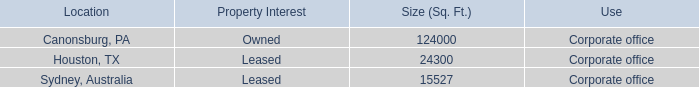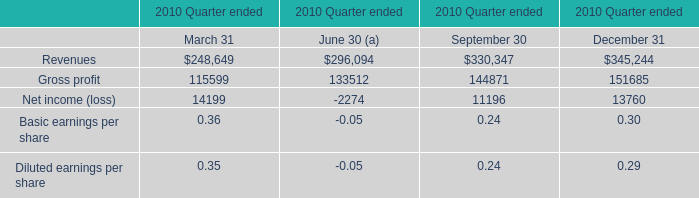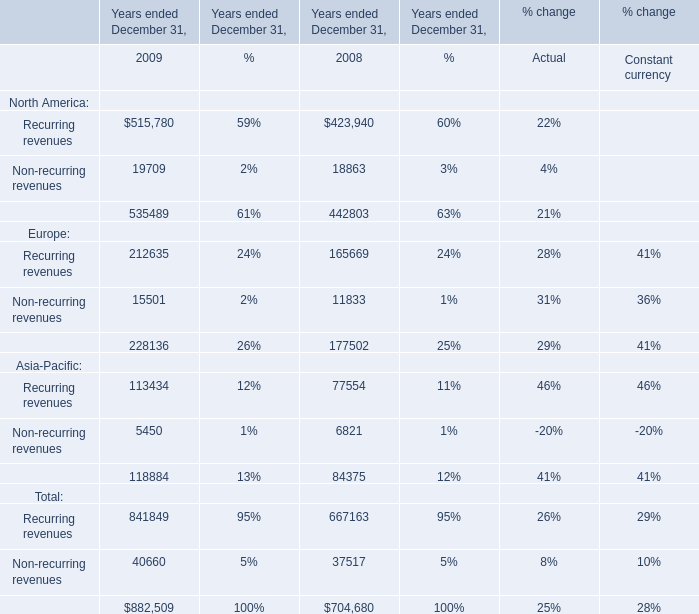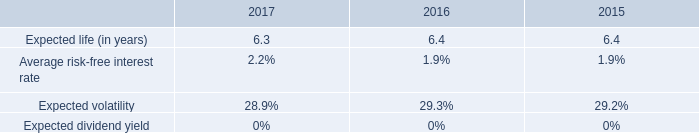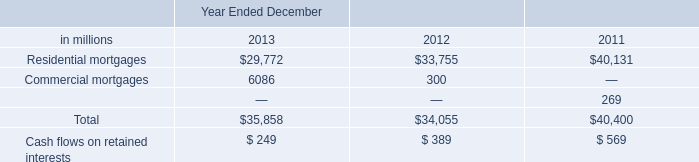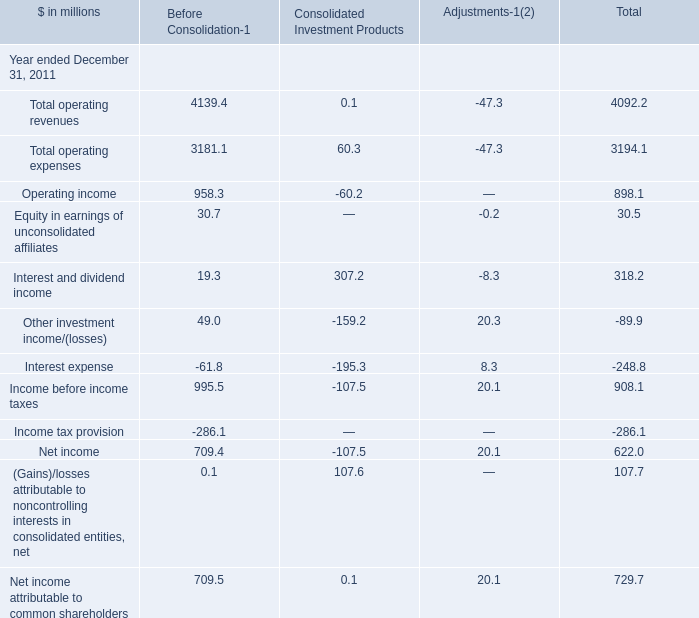If Recurring revenues develops with the same growth rate in 2009, what will it reach in 2010? 
Computations: ((1 + ((515780 - 423940) / 423940)) * 515780)
Answer: 627515.706. 